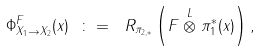<formula> <loc_0><loc_0><loc_500><loc_500>\Phi ^ { F } _ { X _ { 1 } \rightarrow X _ { 2 } } ( x ) \ \colon = \ R _ { \pi _ { 2 , * } } \left ( F \stackrel { L } { \otimes } \pi _ { 1 } ^ { * } ( x ) \right ) ,</formula> 